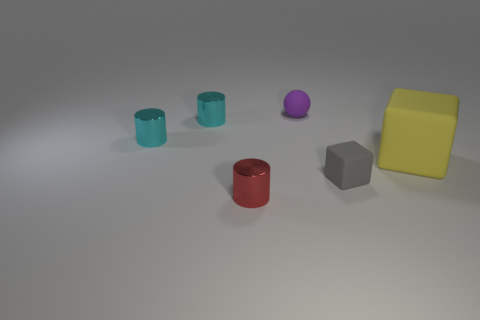Add 2 large green matte objects. How many objects exist? 8 Subtract all blocks. How many objects are left? 4 Add 4 small gray matte things. How many small gray matte things exist? 5 Subtract 0 red balls. How many objects are left? 6 Subtract all small gray matte spheres. Subtract all small metallic objects. How many objects are left? 3 Add 2 red cylinders. How many red cylinders are left? 3 